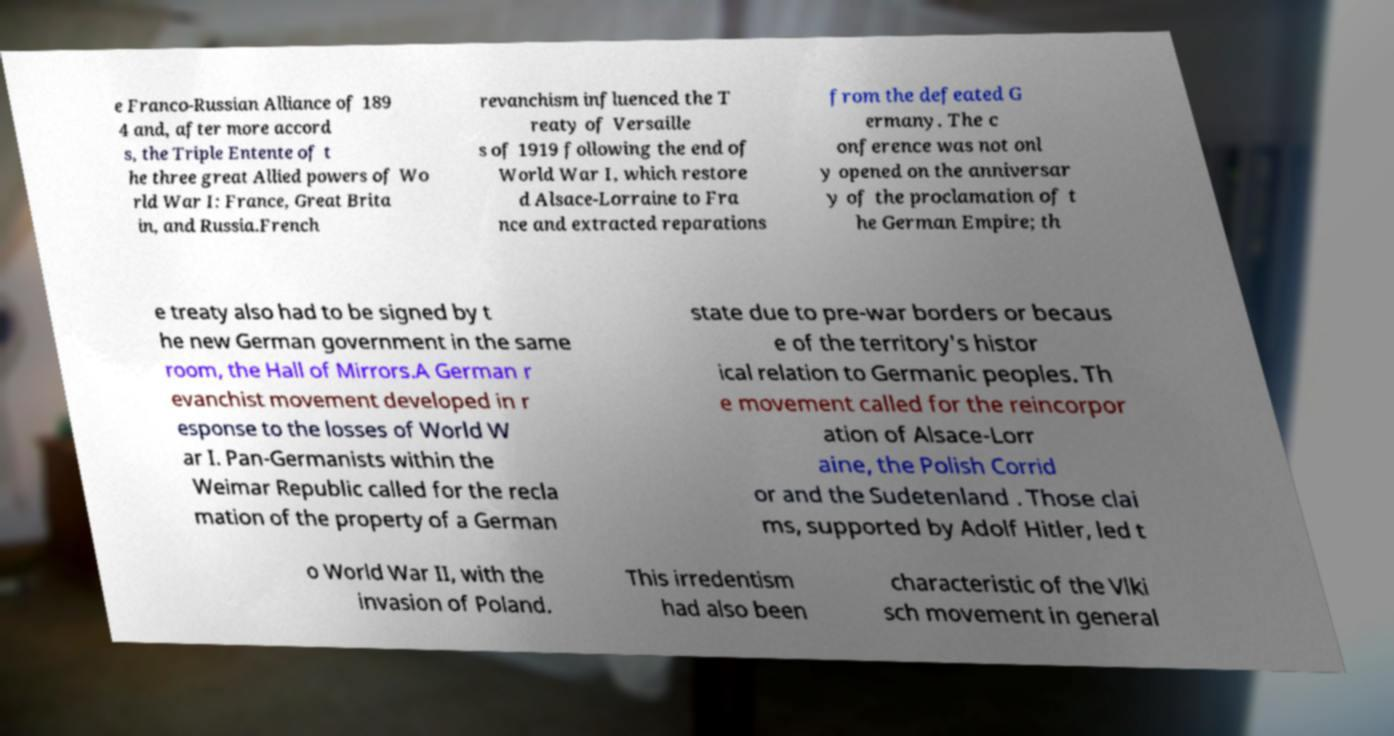For documentation purposes, I need the text within this image transcribed. Could you provide that? e Franco-Russian Alliance of 189 4 and, after more accord s, the Triple Entente of t he three great Allied powers of Wo rld War I: France, Great Brita in, and Russia.French revanchism influenced the T reaty of Versaille s of 1919 following the end of World War I, which restore d Alsace-Lorraine to Fra nce and extracted reparations from the defeated G ermany. The c onference was not onl y opened on the anniversar y of the proclamation of t he German Empire; th e treaty also had to be signed by t he new German government in the same room, the Hall of Mirrors.A German r evanchist movement developed in r esponse to the losses of World W ar I. Pan-Germanists within the Weimar Republic called for the recla mation of the property of a German state due to pre-war borders or becaus e of the territory's histor ical relation to Germanic peoples. Th e movement called for the reincorpor ation of Alsace-Lorr aine, the Polish Corrid or and the Sudetenland . Those clai ms, supported by Adolf Hitler, led t o World War II, with the invasion of Poland. This irredentism had also been characteristic of the Vlki sch movement in general 